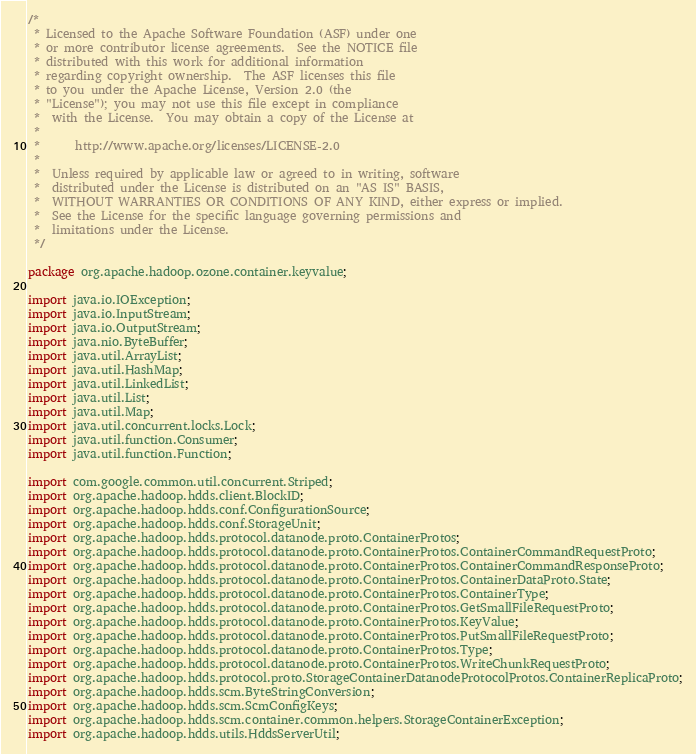Convert code to text. <code><loc_0><loc_0><loc_500><loc_500><_Java_>/*
 * Licensed to the Apache Software Foundation (ASF) under one
 * or more contributor license agreements.  See the NOTICE file
 * distributed with this work for additional information
 * regarding copyright ownership.  The ASF licenses this file
 * to you under the Apache License, Version 2.0 (the
 * "License"); you may not use this file except in compliance
 *  with the License.  You may obtain a copy of the License at
 *
 *      http://www.apache.org/licenses/LICENSE-2.0
 *
 *  Unless required by applicable law or agreed to in writing, software
 *  distributed under the License is distributed on an "AS IS" BASIS,
 *  WITHOUT WARRANTIES OR CONDITIONS OF ANY KIND, either express or implied.
 *  See the License for the specific language governing permissions and
 *  limitations under the License.
 */

package org.apache.hadoop.ozone.container.keyvalue;

import java.io.IOException;
import java.io.InputStream;
import java.io.OutputStream;
import java.nio.ByteBuffer;
import java.util.ArrayList;
import java.util.HashMap;
import java.util.LinkedList;
import java.util.List;
import java.util.Map;
import java.util.concurrent.locks.Lock;
import java.util.function.Consumer;
import java.util.function.Function;

import com.google.common.util.concurrent.Striped;
import org.apache.hadoop.hdds.client.BlockID;
import org.apache.hadoop.hdds.conf.ConfigurationSource;
import org.apache.hadoop.hdds.conf.StorageUnit;
import org.apache.hadoop.hdds.protocol.datanode.proto.ContainerProtos;
import org.apache.hadoop.hdds.protocol.datanode.proto.ContainerProtos.ContainerCommandRequestProto;
import org.apache.hadoop.hdds.protocol.datanode.proto.ContainerProtos.ContainerCommandResponseProto;
import org.apache.hadoop.hdds.protocol.datanode.proto.ContainerProtos.ContainerDataProto.State;
import org.apache.hadoop.hdds.protocol.datanode.proto.ContainerProtos.ContainerType;
import org.apache.hadoop.hdds.protocol.datanode.proto.ContainerProtos.GetSmallFileRequestProto;
import org.apache.hadoop.hdds.protocol.datanode.proto.ContainerProtos.KeyValue;
import org.apache.hadoop.hdds.protocol.datanode.proto.ContainerProtos.PutSmallFileRequestProto;
import org.apache.hadoop.hdds.protocol.datanode.proto.ContainerProtos.Type;
import org.apache.hadoop.hdds.protocol.datanode.proto.ContainerProtos.WriteChunkRequestProto;
import org.apache.hadoop.hdds.protocol.proto.StorageContainerDatanodeProtocolProtos.ContainerReplicaProto;
import org.apache.hadoop.hdds.scm.ByteStringConversion;
import org.apache.hadoop.hdds.scm.ScmConfigKeys;
import org.apache.hadoop.hdds.scm.container.common.helpers.StorageContainerException;
import org.apache.hadoop.hdds.utils.HddsServerUtil;</code> 